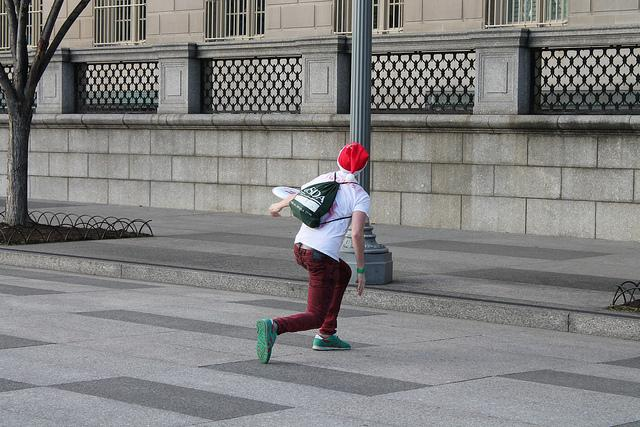What is the man doing? catching frisbee 